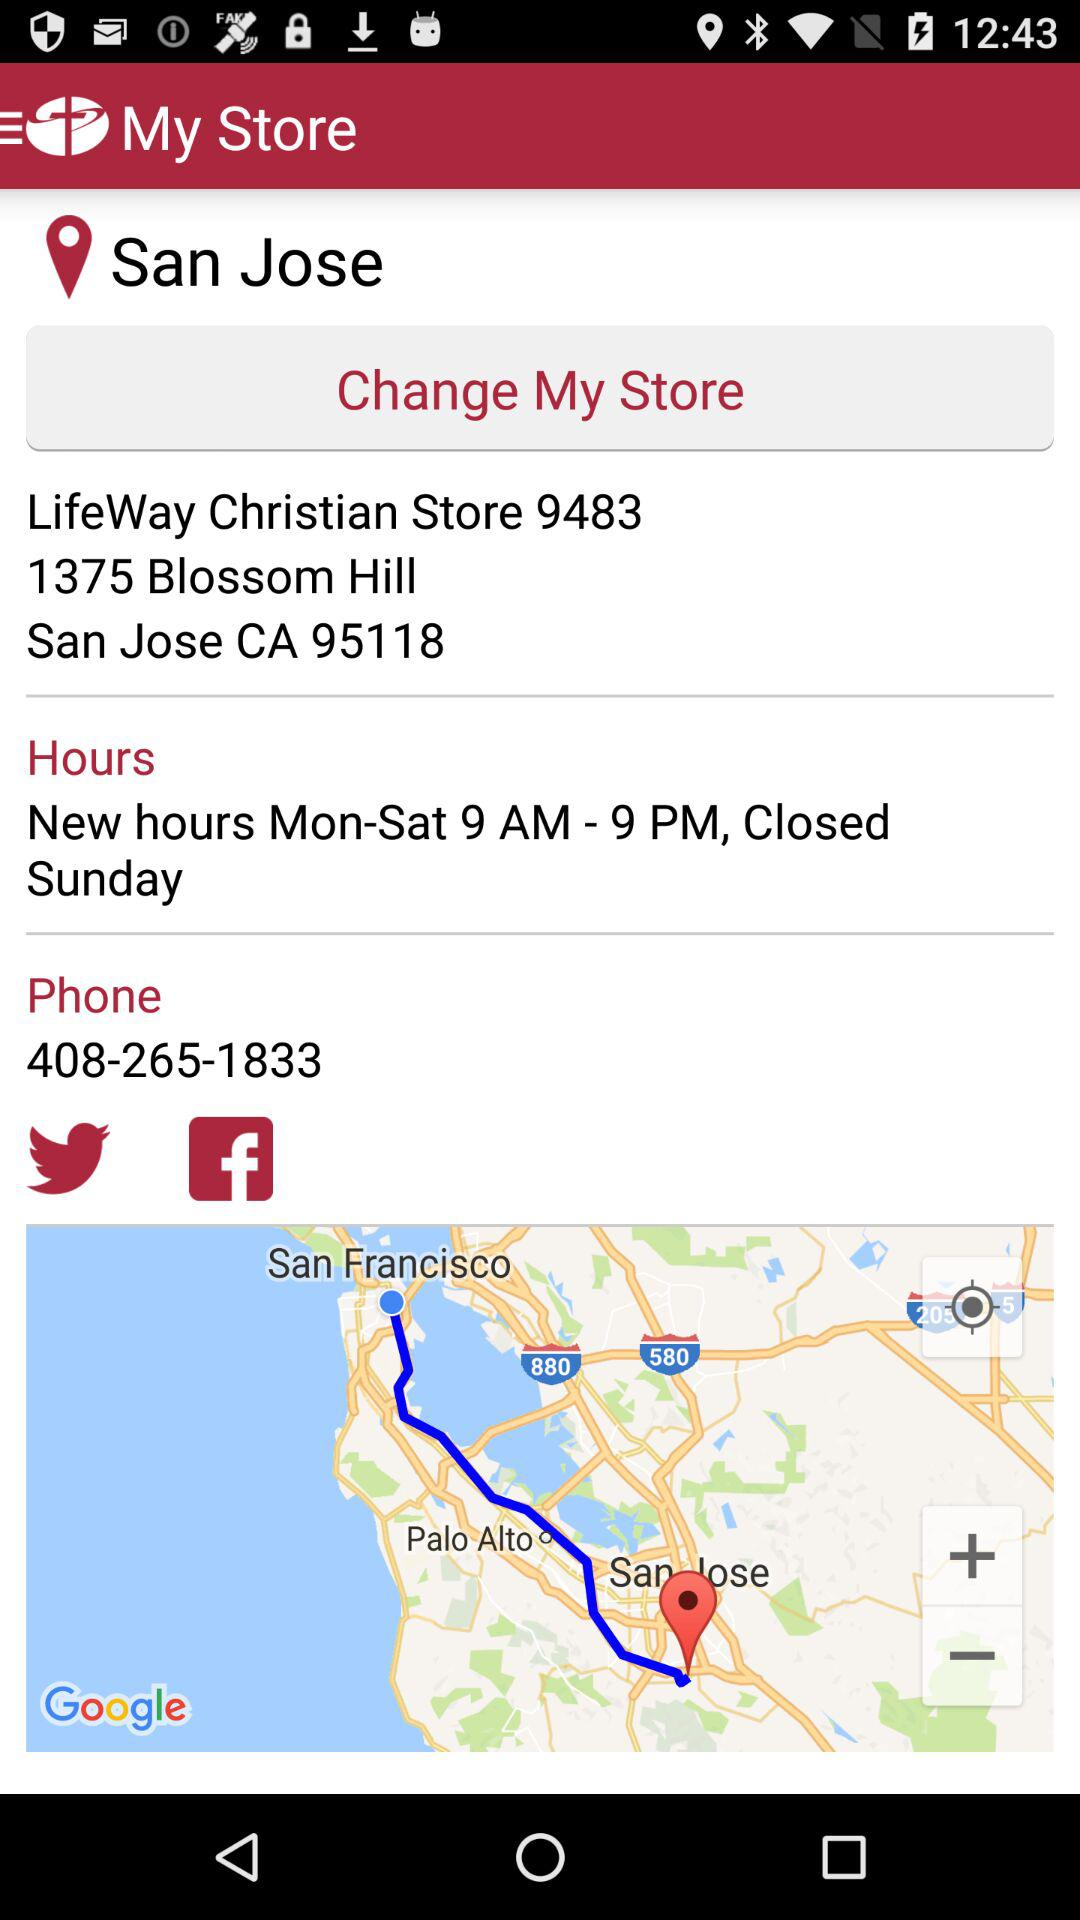On what day is the store closed? The store is closed on Sunday. 